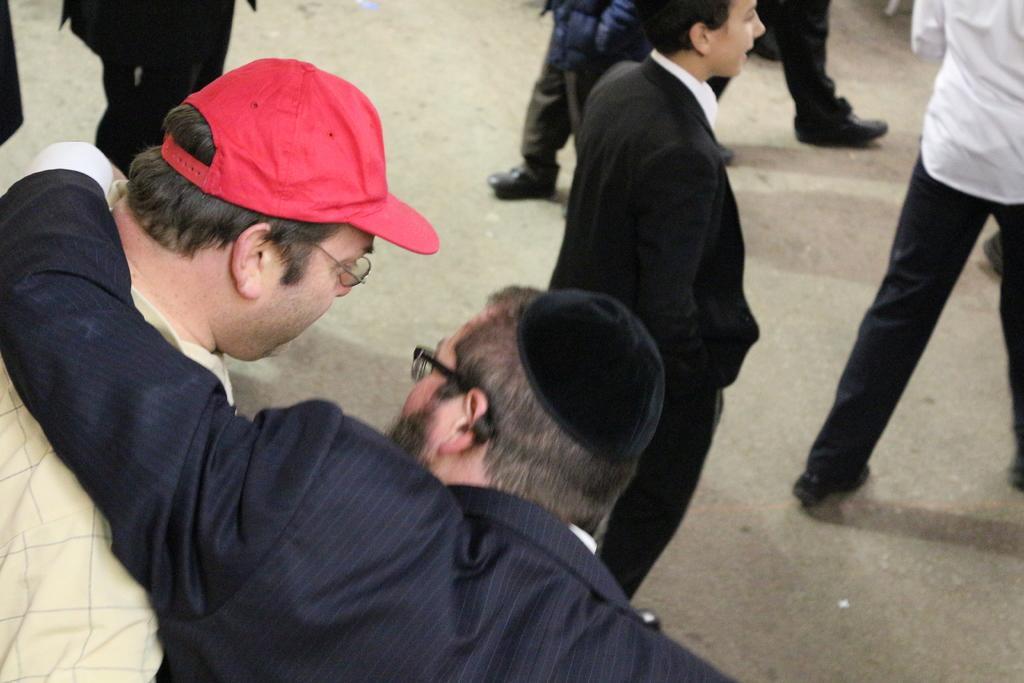Can you describe this image briefly? The person wearing black suit placed his hand on another person beside him and there are few other persons in front of them. 